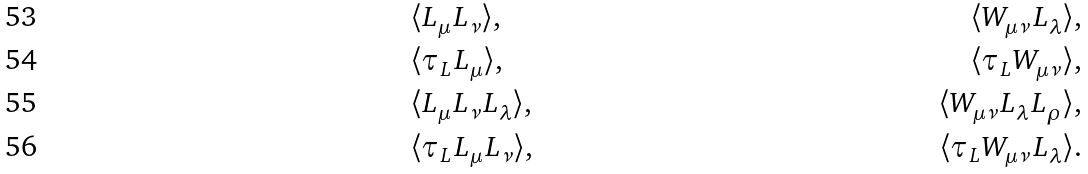<formula> <loc_0><loc_0><loc_500><loc_500>& \langle L _ { \mu } L _ { \nu } \rangle , & \langle W _ { \mu \nu } L _ { \lambda } \rangle , \\ & \langle \tau _ { L } L _ { \mu } \rangle , & \langle \tau _ { L } W _ { \mu \nu } \rangle , \\ & \langle L _ { \mu } L _ { \nu } L _ { \lambda } \rangle , & \langle W _ { \mu \nu } L _ { \lambda } L _ { \rho } \rangle , \\ & \langle \tau _ { L } L _ { \mu } L _ { \nu } \rangle , & \langle \tau _ { L } W _ { \mu \nu } L _ { \lambda } \rangle .</formula> 